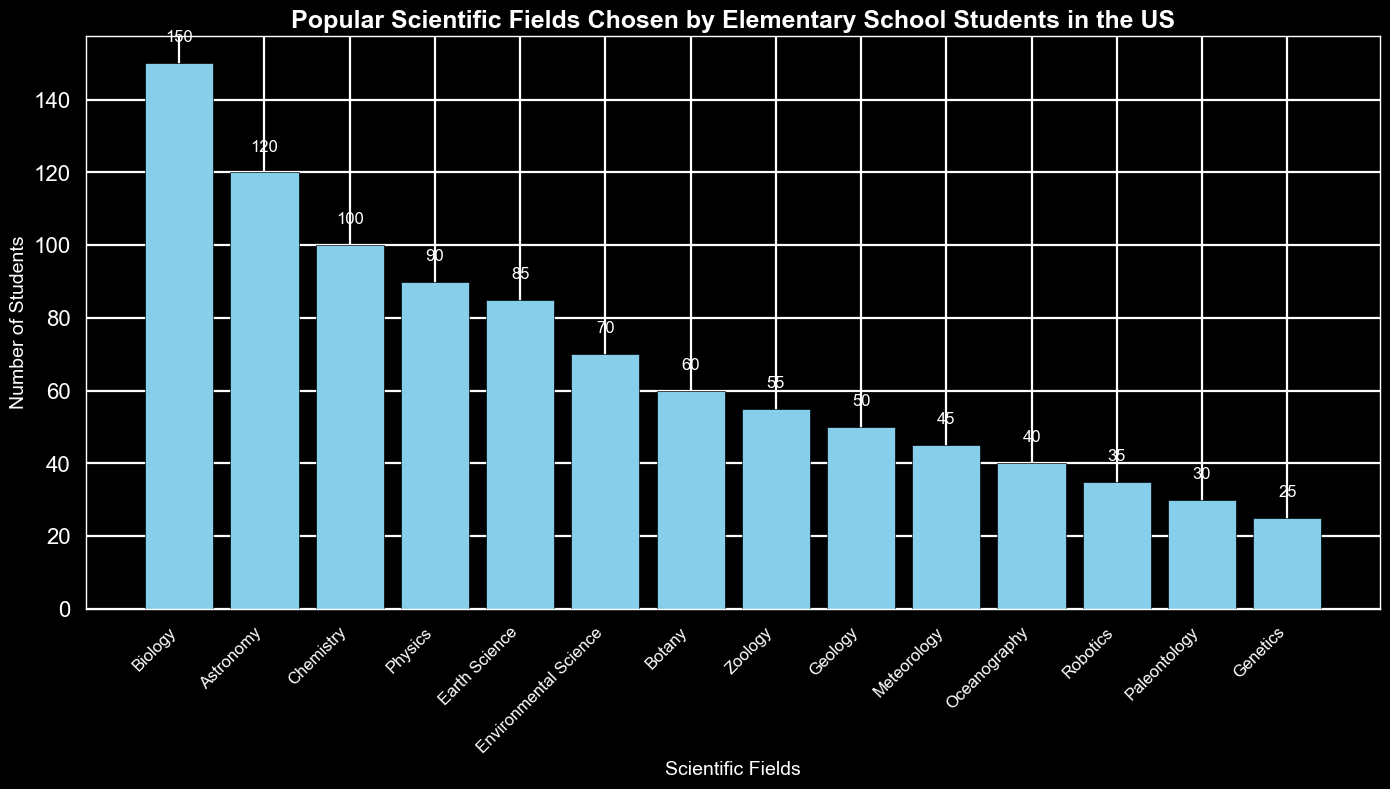Which scientific field has the highest number of students? The figure shows that the bar representing Biology is the tallest, indicating it has the highest number of students.
Answer: Biology Which field is more popular: Chemistry or Zoology? By comparing the heights of the bars, the bar for Chemistry is taller than the one for Zoology, indicating more students chose Chemistry.
Answer: Chemistry How many more students chose Astronomy than Botany? The bar for Astronomy shows 120 students while the bar for Botany shows 60. Subtracting the number of Botany students from the number of Astronomy students gives 120 - 60.
Answer: 60 What's the total number of students interested in Meteorology and Oceanography combined? The figure shows Meteorology has 45 students and Oceanography has 40 students. Summing these numbers gives 45 + 40.
Answer: 85 Which field is chosen by fewer students: Robotics or Genetics? Comparing the heights of the bars for Robotics and Genetics, the bar for Genetics is shorter. Thus, fewer students chose Genetics.
Answer: Genetics How does the interest in Earth Science compare to Environmental Science? By comparing the heights of the bars, Earth Science has 85 students and Environmental Science has 70 students. Earth Science is more popular.
Answer: Earth Science What is the difference in the number of students between the most popular and least popular scientific fields? The most popular field, Biology, has 150 students, and the least popular field, Genetics, has 25 students. The difference is 150 - 25.
Answer: 125 What is the average number of students per field for Astronomy, Chemistry, and Physics? The number of students for Astronomy is 120, Chemistry is 100, and Physics is 90. The average is calculated as (120 + 100 + 90) / 3.
Answer: 103.33 Which field has almost the same number of students as Geology? The figure shows that Geology has 50 students. The bar for Zoology is closest with 55 students.
Answer: Zoology 